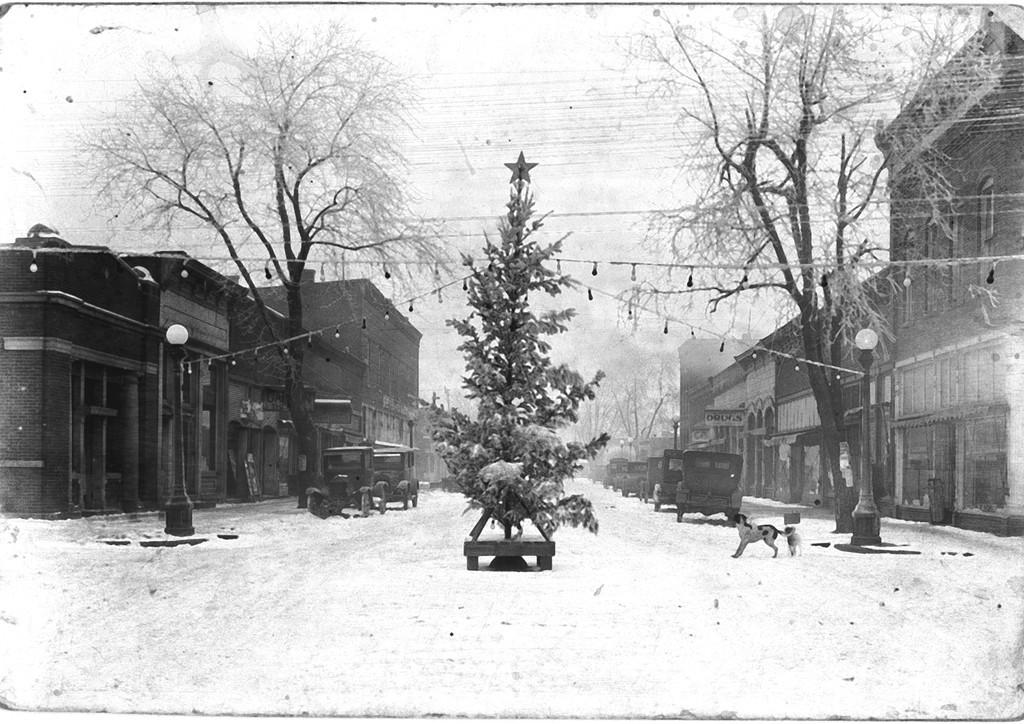What type of structures can be seen in the image? There are buildings with windows in the image. What else is present on the roads in the image? The roads are covered with snow in the image. What other objects can be seen on the roads? There are vehicles in the image. Are there any animals present in the image? Yes, there are dogs in the image. What other objects can be seen in the image? There are poles in the image. What might be used for illumination in the image? There are lights in the image. What type of natural elements can be seen in the image? There are trees in the image. What part of the environment is visible in the image? The sky is visible in the image. What type of pen can be seen in the image? There is no pen present in the image. What sound can be heard coming from the vehicles in the image? The image is static, so no sound can be heard. 